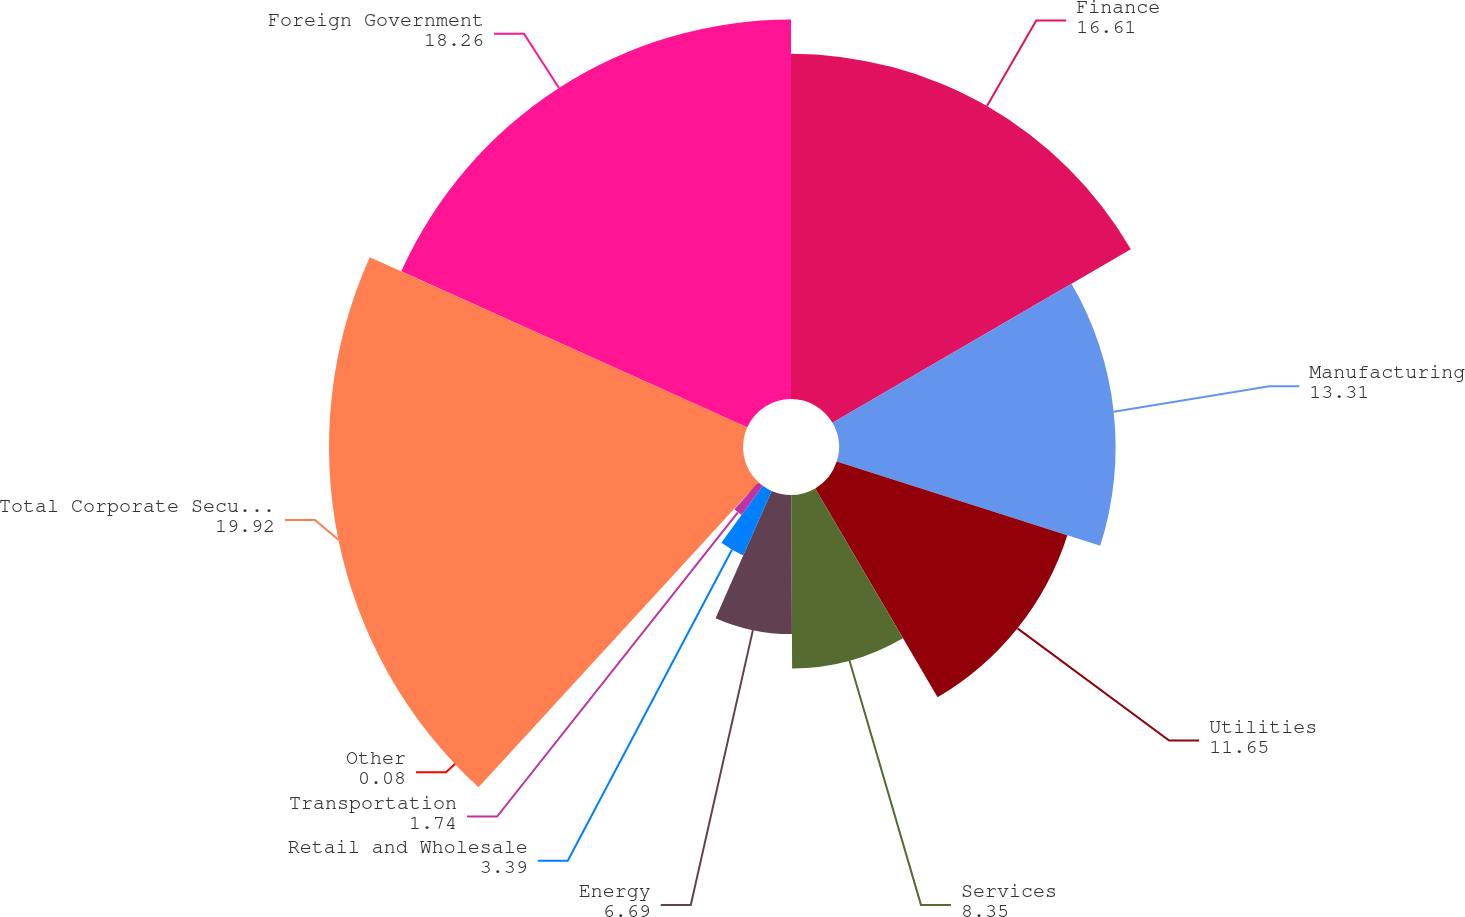<chart> <loc_0><loc_0><loc_500><loc_500><pie_chart><fcel>Finance<fcel>Manufacturing<fcel>Utilities<fcel>Services<fcel>Energy<fcel>Retail and Wholesale<fcel>Transportation<fcel>Other<fcel>Total Corporate Securities<fcel>Foreign Government<nl><fcel>16.61%<fcel>13.31%<fcel>11.65%<fcel>8.35%<fcel>6.69%<fcel>3.39%<fcel>1.74%<fcel>0.08%<fcel>19.92%<fcel>18.26%<nl></chart> 